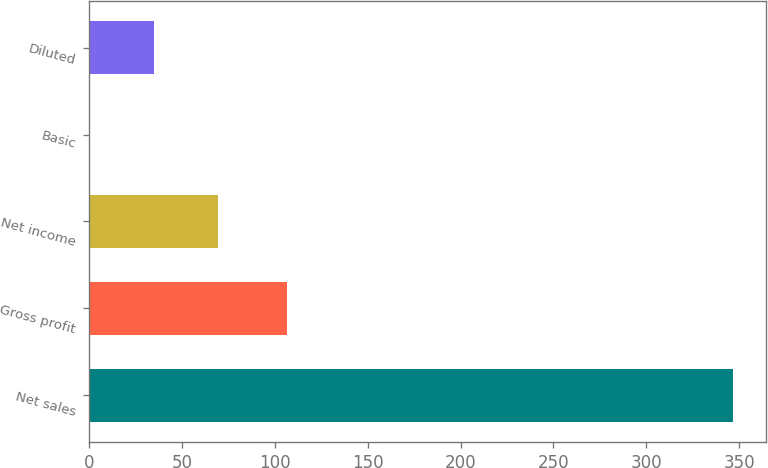Convert chart to OTSL. <chart><loc_0><loc_0><loc_500><loc_500><bar_chart><fcel>Net sales<fcel>Gross profit<fcel>Net income<fcel>Basic<fcel>Diluted<nl><fcel>346.8<fcel>106.4<fcel>69.66<fcel>0.38<fcel>35.02<nl></chart> 